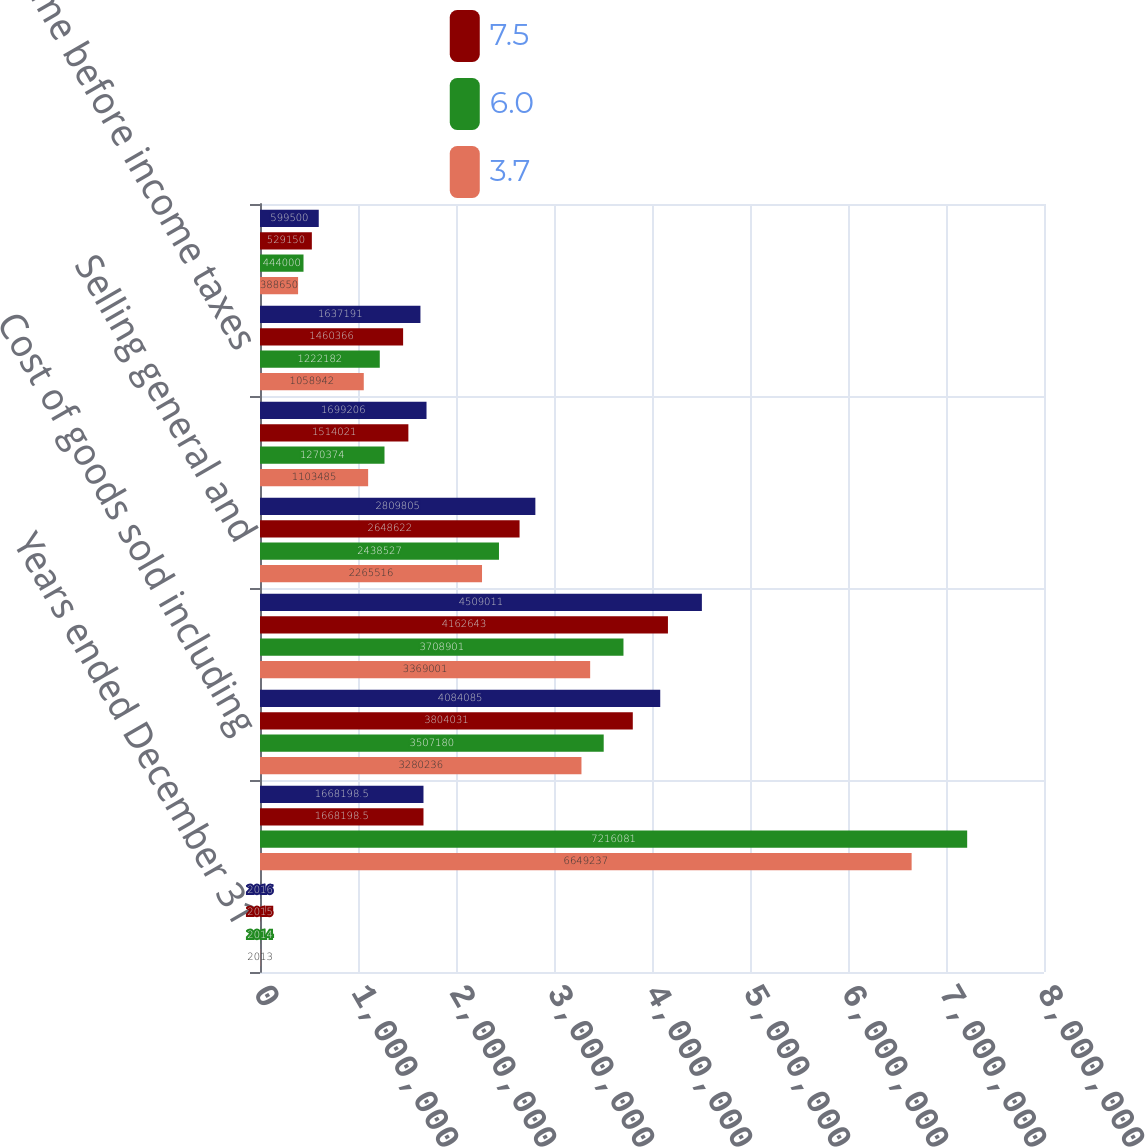Convert chart to OTSL. <chart><loc_0><loc_0><loc_500><loc_500><stacked_bar_chart><ecel><fcel>Years ended December 31<fcel>Sales ()<fcel>Cost of goods sold including<fcel>Gross profit<fcel>Selling general and<fcel>Operating income<fcel>Income before income taxes<fcel>Provision for income taxes<nl><fcel>nan<fcel>2016<fcel>1.6682e+06<fcel>4.08408e+06<fcel>4.50901e+06<fcel>2.8098e+06<fcel>1.69921e+06<fcel>1.63719e+06<fcel>599500<nl><fcel>7.5<fcel>2015<fcel>1.6682e+06<fcel>3.80403e+06<fcel>4.16264e+06<fcel>2.64862e+06<fcel>1.51402e+06<fcel>1.46037e+06<fcel>529150<nl><fcel>6<fcel>2014<fcel>7.21608e+06<fcel>3.50718e+06<fcel>3.7089e+06<fcel>2.43853e+06<fcel>1.27037e+06<fcel>1.22218e+06<fcel>444000<nl><fcel>3.7<fcel>2013<fcel>6.64924e+06<fcel>3.28024e+06<fcel>3.369e+06<fcel>2.26552e+06<fcel>1.10348e+06<fcel>1.05894e+06<fcel>388650<nl></chart> 